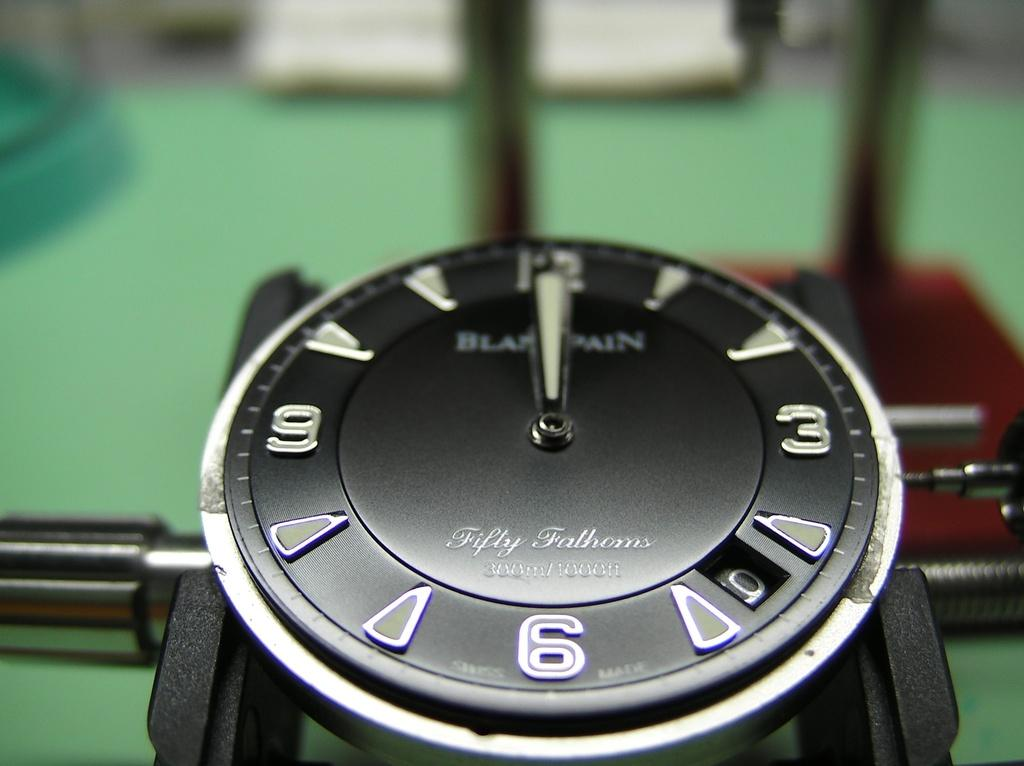<image>
Summarize the visual content of the image. A black watch the says Fifty Fathoms sits on a work desj 